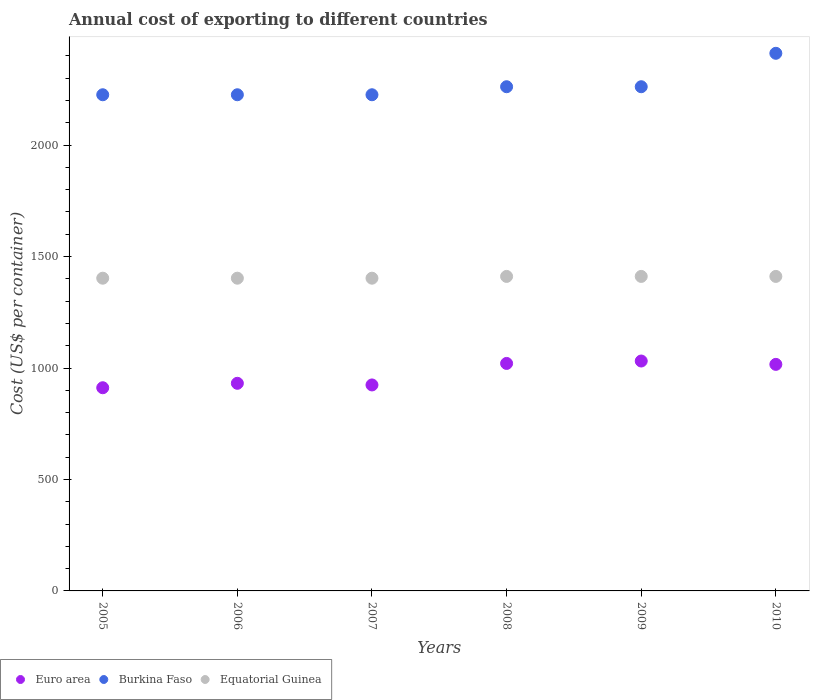Is the number of dotlines equal to the number of legend labels?
Keep it short and to the point. Yes. What is the total annual cost of exporting in Burkina Faso in 2009?
Your answer should be very brief. 2262. Across all years, what is the maximum total annual cost of exporting in Equatorial Guinea?
Offer a very short reply. 1411. Across all years, what is the minimum total annual cost of exporting in Equatorial Guinea?
Your answer should be compact. 1403. What is the total total annual cost of exporting in Burkina Faso in the graph?
Offer a very short reply. 1.36e+04. What is the difference between the total annual cost of exporting in Euro area in 2007 and that in 2009?
Your response must be concise. -107.33. What is the difference between the total annual cost of exporting in Euro area in 2006 and the total annual cost of exporting in Equatorial Guinea in 2005?
Offer a very short reply. -471.53. What is the average total annual cost of exporting in Equatorial Guinea per year?
Your response must be concise. 1407. In the year 2008, what is the difference between the total annual cost of exporting in Equatorial Guinea and total annual cost of exporting in Euro area?
Your answer should be very brief. 390.39. In how many years, is the total annual cost of exporting in Equatorial Guinea greater than 100 US$?
Provide a short and direct response. 6. What is the ratio of the total annual cost of exporting in Burkina Faso in 2005 to that in 2008?
Keep it short and to the point. 0.98. What is the difference between the highest and the second highest total annual cost of exporting in Burkina Faso?
Provide a succinct answer. 150. What is the difference between the highest and the lowest total annual cost of exporting in Euro area?
Your response must be concise. 119.88. In how many years, is the total annual cost of exporting in Burkina Faso greater than the average total annual cost of exporting in Burkina Faso taken over all years?
Ensure brevity in your answer.  1. How are the legend labels stacked?
Offer a very short reply. Horizontal. What is the title of the graph?
Make the answer very short. Annual cost of exporting to different countries. Does "Belarus" appear as one of the legend labels in the graph?
Your answer should be compact. No. What is the label or title of the X-axis?
Make the answer very short. Years. What is the label or title of the Y-axis?
Provide a short and direct response. Cost (US$ per container). What is the Cost (US$ per container) of Euro area in 2005?
Your answer should be very brief. 911.56. What is the Cost (US$ per container) in Burkina Faso in 2005?
Ensure brevity in your answer.  2226. What is the Cost (US$ per container) of Equatorial Guinea in 2005?
Provide a short and direct response. 1403. What is the Cost (US$ per container) in Euro area in 2006?
Make the answer very short. 931.47. What is the Cost (US$ per container) in Burkina Faso in 2006?
Provide a short and direct response. 2226. What is the Cost (US$ per container) in Equatorial Guinea in 2006?
Provide a succinct answer. 1403. What is the Cost (US$ per container) in Euro area in 2007?
Offer a terse response. 924.12. What is the Cost (US$ per container) of Burkina Faso in 2007?
Give a very brief answer. 2226. What is the Cost (US$ per container) of Equatorial Guinea in 2007?
Keep it short and to the point. 1403. What is the Cost (US$ per container) in Euro area in 2008?
Provide a succinct answer. 1020.61. What is the Cost (US$ per container) in Burkina Faso in 2008?
Offer a terse response. 2262. What is the Cost (US$ per container) of Equatorial Guinea in 2008?
Provide a short and direct response. 1411. What is the Cost (US$ per container) of Euro area in 2009?
Ensure brevity in your answer.  1031.44. What is the Cost (US$ per container) in Burkina Faso in 2009?
Make the answer very short. 2262. What is the Cost (US$ per container) in Equatorial Guinea in 2009?
Make the answer very short. 1411. What is the Cost (US$ per container) of Euro area in 2010?
Keep it short and to the point. 1016.39. What is the Cost (US$ per container) of Burkina Faso in 2010?
Your answer should be very brief. 2412. What is the Cost (US$ per container) in Equatorial Guinea in 2010?
Provide a succinct answer. 1411. Across all years, what is the maximum Cost (US$ per container) of Euro area?
Provide a succinct answer. 1031.44. Across all years, what is the maximum Cost (US$ per container) of Burkina Faso?
Provide a short and direct response. 2412. Across all years, what is the maximum Cost (US$ per container) of Equatorial Guinea?
Your response must be concise. 1411. Across all years, what is the minimum Cost (US$ per container) in Euro area?
Give a very brief answer. 911.56. Across all years, what is the minimum Cost (US$ per container) in Burkina Faso?
Your answer should be compact. 2226. Across all years, what is the minimum Cost (US$ per container) in Equatorial Guinea?
Ensure brevity in your answer.  1403. What is the total Cost (US$ per container) in Euro area in the graph?
Offer a very short reply. 5835.6. What is the total Cost (US$ per container) of Burkina Faso in the graph?
Give a very brief answer. 1.36e+04. What is the total Cost (US$ per container) of Equatorial Guinea in the graph?
Offer a very short reply. 8442. What is the difference between the Cost (US$ per container) of Euro area in 2005 and that in 2006?
Provide a succinct answer. -19.91. What is the difference between the Cost (US$ per container) in Euro area in 2005 and that in 2007?
Offer a terse response. -12.56. What is the difference between the Cost (US$ per container) in Equatorial Guinea in 2005 and that in 2007?
Your response must be concise. 0. What is the difference between the Cost (US$ per container) of Euro area in 2005 and that in 2008?
Make the answer very short. -109.05. What is the difference between the Cost (US$ per container) of Burkina Faso in 2005 and that in 2008?
Offer a terse response. -36. What is the difference between the Cost (US$ per container) in Euro area in 2005 and that in 2009?
Give a very brief answer. -119.88. What is the difference between the Cost (US$ per container) of Burkina Faso in 2005 and that in 2009?
Your answer should be very brief. -36. What is the difference between the Cost (US$ per container) of Equatorial Guinea in 2005 and that in 2009?
Offer a terse response. -8. What is the difference between the Cost (US$ per container) of Euro area in 2005 and that in 2010?
Keep it short and to the point. -104.83. What is the difference between the Cost (US$ per container) of Burkina Faso in 2005 and that in 2010?
Keep it short and to the point. -186. What is the difference between the Cost (US$ per container) of Euro area in 2006 and that in 2007?
Keep it short and to the point. 7.35. What is the difference between the Cost (US$ per container) of Burkina Faso in 2006 and that in 2007?
Give a very brief answer. 0. What is the difference between the Cost (US$ per container) of Equatorial Guinea in 2006 and that in 2007?
Ensure brevity in your answer.  0. What is the difference between the Cost (US$ per container) in Euro area in 2006 and that in 2008?
Ensure brevity in your answer.  -89.14. What is the difference between the Cost (US$ per container) in Burkina Faso in 2006 and that in 2008?
Make the answer very short. -36. What is the difference between the Cost (US$ per container) of Euro area in 2006 and that in 2009?
Your answer should be compact. -99.97. What is the difference between the Cost (US$ per container) in Burkina Faso in 2006 and that in 2009?
Give a very brief answer. -36. What is the difference between the Cost (US$ per container) in Euro area in 2006 and that in 2010?
Make the answer very short. -84.92. What is the difference between the Cost (US$ per container) in Burkina Faso in 2006 and that in 2010?
Offer a very short reply. -186. What is the difference between the Cost (US$ per container) of Equatorial Guinea in 2006 and that in 2010?
Your answer should be very brief. -8. What is the difference between the Cost (US$ per container) of Euro area in 2007 and that in 2008?
Your answer should be compact. -96.49. What is the difference between the Cost (US$ per container) of Burkina Faso in 2007 and that in 2008?
Your response must be concise. -36. What is the difference between the Cost (US$ per container) of Equatorial Guinea in 2007 and that in 2008?
Your answer should be compact. -8. What is the difference between the Cost (US$ per container) in Euro area in 2007 and that in 2009?
Your answer should be very brief. -107.33. What is the difference between the Cost (US$ per container) in Burkina Faso in 2007 and that in 2009?
Make the answer very short. -36. What is the difference between the Cost (US$ per container) in Euro area in 2007 and that in 2010?
Provide a short and direct response. -92.27. What is the difference between the Cost (US$ per container) of Burkina Faso in 2007 and that in 2010?
Offer a terse response. -186. What is the difference between the Cost (US$ per container) of Equatorial Guinea in 2007 and that in 2010?
Offer a very short reply. -8. What is the difference between the Cost (US$ per container) in Euro area in 2008 and that in 2009?
Offer a terse response. -10.83. What is the difference between the Cost (US$ per container) of Euro area in 2008 and that in 2010?
Your response must be concise. 4.22. What is the difference between the Cost (US$ per container) in Burkina Faso in 2008 and that in 2010?
Ensure brevity in your answer.  -150. What is the difference between the Cost (US$ per container) of Equatorial Guinea in 2008 and that in 2010?
Provide a short and direct response. 0. What is the difference between the Cost (US$ per container) in Euro area in 2009 and that in 2010?
Ensure brevity in your answer.  15.06. What is the difference between the Cost (US$ per container) in Burkina Faso in 2009 and that in 2010?
Offer a very short reply. -150. What is the difference between the Cost (US$ per container) in Euro area in 2005 and the Cost (US$ per container) in Burkina Faso in 2006?
Your answer should be very brief. -1314.44. What is the difference between the Cost (US$ per container) in Euro area in 2005 and the Cost (US$ per container) in Equatorial Guinea in 2006?
Offer a very short reply. -491.44. What is the difference between the Cost (US$ per container) in Burkina Faso in 2005 and the Cost (US$ per container) in Equatorial Guinea in 2006?
Your answer should be compact. 823. What is the difference between the Cost (US$ per container) in Euro area in 2005 and the Cost (US$ per container) in Burkina Faso in 2007?
Offer a terse response. -1314.44. What is the difference between the Cost (US$ per container) of Euro area in 2005 and the Cost (US$ per container) of Equatorial Guinea in 2007?
Your answer should be compact. -491.44. What is the difference between the Cost (US$ per container) of Burkina Faso in 2005 and the Cost (US$ per container) of Equatorial Guinea in 2007?
Make the answer very short. 823. What is the difference between the Cost (US$ per container) of Euro area in 2005 and the Cost (US$ per container) of Burkina Faso in 2008?
Your answer should be compact. -1350.44. What is the difference between the Cost (US$ per container) in Euro area in 2005 and the Cost (US$ per container) in Equatorial Guinea in 2008?
Your answer should be very brief. -499.44. What is the difference between the Cost (US$ per container) of Burkina Faso in 2005 and the Cost (US$ per container) of Equatorial Guinea in 2008?
Give a very brief answer. 815. What is the difference between the Cost (US$ per container) of Euro area in 2005 and the Cost (US$ per container) of Burkina Faso in 2009?
Offer a very short reply. -1350.44. What is the difference between the Cost (US$ per container) of Euro area in 2005 and the Cost (US$ per container) of Equatorial Guinea in 2009?
Offer a terse response. -499.44. What is the difference between the Cost (US$ per container) in Burkina Faso in 2005 and the Cost (US$ per container) in Equatorial Guinea in 2009?
Keep it short and to the point. 815. What is the difference between the Cost (US$ per container) of Euro area in 2005 and the Cost (US$ per container) of Burkina Faso in 2010?
Your response must be concise. -1500.44. What is the difference between the Cost (US$ per container) of Euro area in 2005 and the Cost (US$ per container) of Equatorial Guinea in 2010?
Your answer should be very brief. -499.44. What is the difference between the Cost (US$ per container) in Burkina Faso in 2005 and the Cost (US$ per container) in Equatorial Guinea in 2010?
Provide a succinct answer. 815. What is the difference between the Cost (US$ per container) of Euro area in 2006 and the Cost (US$ per container) of Burkina Faso in 2007?
Offer a terse response. -1294.53. What is the difference between the Cost (US$ per container) in Euro area in 2006 and the Cost (US$ per container) in Equatorial Guinea in 2007?
Give a very brief answer. -471.53. What is the difference between the Cost (US$ per container) in Burkina Faso in 2006 and the Cost (US$ per container) in Equatorial Guinea in 2007?
Your answer should be very brief. 823. What is the difference between the Cost (US$ per container) in Euro area in 2006 and the Cost (US$ per container) in Burkina Faso in 2008?
Keep it short and to the point. -1330.53. What is the difference between the Cost (US$ per container) in Euro area in 2006 and the Cost (US$ per container) in Equatorial Guinea in 2008?
Your response must be concise. -479.53. What is the difference between the Cost (US$ per container) in Burkina Faso in 2006 and the Cost (US$ per container) in Equatorial Guinea in 2008?
Offer a very short reply. 815. What is the difference between the Cost (US$ per container) of Euro area in 2006 and the Cost (US$ per container) of Burkina Faso in 2009?
Provide a succinct answer. -1330.53. What is the difference between the Cost (US$ per container) of Euro area in 2006 and the Cost (US$ per container) of Equatorial Guinea in 2009?
Offer a very short reply. -479.53. What is the difference between the Cost (US$ per container) of Burkina Faso in 2006 and the Cost (US$ per container) of Equatorial Guinea in 2009?
Your answer should be compact. 815. What is the difference between the Cost (US$ per container) in Euro area in 2006 and the Cost (US$ per container) in Burkina Faso in 2010?
Your answer should be compact. -1480.53. What is the difference between the Cost (US$ per container) of Euro area in 2006 and the Cost (US$ per container) of Equatorial Guinea in 2010?
Your response must be concise. -479.53. What is the difference between the Cost (US$ per container) in Burkina Faso in 2006 and the Cost (US$ per container) in Equatorial Guinea in 2010?
Provide a succinct answer. 815. What is the difference between the Cost (US$ per container) in Euro area in 2007 and the Cost (US$ per container) in Burkina Faso in 2008?
Ensure brevity in your answer.  -1337.88. What is the difference between the Cost (US$ per container) in Euro area in 2007 and the Cost (US$ per container) in Equatorial Guinea in 2008?
Your response must be concise. -486.88. What is the difference between the Cost (US$ per container) of Burkina Faso in 2007 and the Cost (US$ per container) of Equatorial Guinea in 2008?
Your response must be concise. 815. What is the difference between the Cost (US$ per container) of Euro area in 2007 and the Cost (US$ per container) of Burkina Faso in 2009?
Make the answer very short. -1337.88. What is the difference between the Cost (US$ per container) of Euro area in 2007 and the Cost (US$ per container) of Equatorial Guinea in 2009?
Offer a terse response. -486.88. What is the difference between the Cost (US$ per container) of Burkina Faso in 2007 and the Cost (US$ per container) of Equatorial Guinea in 2009?
Make the answer very short. 815. What is the difference between the Cost (US$ per container) of Euro area in 2007 and the Cost (US$ per container) of Burkina Faso in 2010?
Provide a succinct answer. -1487.88. What is the difference between the Cost (US$ per container) of Euro area in 2007 and the Cost (US$ per container) of Equatorial Guinea in 2010?
Give a very brief answer. -486.88. What is the difference between the Cost (US$ per container) in Burkina Faso in 2007 and the Cost (US$ per container) in Equatorial Guinea in 2010?
Give a very brief answer. 815. What is the difference between the Cost (US$ per container) in Euro area in 2008 and the Cost (US$ per container) in Burkina Faso in 2009?
Your answer should be very brief. -1241.39. What is the difference between the Cost (US$ per container) of Euro area in 2008 and the Cost (US$ per container) of Equatorial Guinea in 2009?
Offer a terse response. -390.39. What is the difference between the Cost (US$ per container) in Burkina Faso in 2008 and the Cost (US$ per container) in Equatorial Guinea in 2009?
Give a very brief answer. 851. What is the difference between the Cost (US$ per container) of Euro area in 2008 and the Cost (US$ per container) of Burkina Faso in 2010?
Offer a very short reply. -1391.39. What is the difference between the Cost (US$ per container) of Euro area in 2008 and the Cost (US$ per container) of Equatorial Guinea in 2010?
Your response must be concise. -390.39. What is the difference between the Cost (US$ per container) of Burkina Faso in 2008 and the Cost (US$ per container) of Equatorial Guinea in 2010?
Keep it short and to the point. 851. What is the difference between the Cost (US$ per container) of Euro area in 2009 and the Cost (US$ per container) of Burkina Faso in 2010?
Give a very brief answer. -1380.56. What is the difference between the Cost (US$ per container) of Euro area in 2009 and the Cost (US$ per container) of Equatorial Guinea in 2010?
Provide a succinct answer. -379.56. What is the difference between the Cost (US$ per container) of Burkina Faso in 2009 and the Cost (US$ per container) of Equatorial Guinea in 2010?
Your response must be concise. 851. What is the average Cost (US$ per container) in Euro area per year?
Provide a succinct answer. 972.6. What is the average Cost (US$ per container) in Burkina Faso per year?
Your answer should be very brief. 2269. What is the average Cost (US$ per container) of Equatorial Guinea per year?
Keep it short and to the point. 1407. In the year 2005, what is the difference between the Cost (US$ per container) in Euro area and Cost (US$ per container) in Burkina Faso?
Your response must be concise. -1314.44. In the year 2005, what is the difference between the Cost (US$ per container) of Euro area and Cost (US$ per container) of Equatorial Guinea?
Keep it short and to the point. -491.44. In the year 2005, what is the difference between the Cost (US$ per container) in Burkina Faso and Cost (US$ per container) in Equatorial Guinea?
Your answer should be very brief. 823. In the year 2006, what is the difference between the Cost (US$ per container) of Euro area and Cost (US$ per container) of Burkina Faso?
Provide a succinct answer. -1294.53. In the year 2006, what is the difference between the Cost (US$ per container) of Euro area and Cost (US$ per container) of Equatorial Guinea?
Your response must be concise. -471.53. In the year 2006, what is the difference between the Cost (US$ per container) in Burkina Faso and Cost (US$ per container) in Equatorial Guinea?
Offer a terse response. 823. In the year 2007, what is the difference between the Cost (US$ per container) of Euro area and Cost (US$ per container) of Burkina Faso?
Your answer should be compact. -1301.88. In the year 2007, what is the difference between the Cost (US$ per container) in Euro area and Cost (US$ per container) in Equatorial Guinea?
Ensure brevity in your answer.  -478.88. In the year 2007, what is the difference between the Cost (US$ per container) in Burkina Faso and Cost (US$ per container) in Equatorial Guinea?
Offer a very short reply. 823. In the year 2008, what is the difference between the Cost (US$ per container) of Euro area and Cost (US$ per container) of Burkina Faso?
Make the answer very short. -1241.39. In the year 2008, what is the difference between the Cost (US$ per container) in Euro area and Cost (US$ per container) in Equatorial Guinea?
Offer a very short reply. -390.39. In the year 2008, what is the difference between the Cost (US$ per container) of Burkina Faso and Cost (US$ per container) of Equatorial Guinea?
Your answer should be very brief. 851. In the year 2009, what is the difference between the Cost (US$ per container) in Euro area and Cost (US$ per container) in Burkina Faso?
Offer a very short reply. -1230.56. In the year 2009, what is the difference between the Cost (US$ per container) of Euro area and Cost (US$ per container) of Equatorial Guinea?
Give a very brief answer. -379.56. In the year 2009, what is the difference between the Cost (US$ per container) of Burkina Faso and Cost (US$ per container) of Equatorial Guinea?
Your answer should be compact. 851. In the year 2010, what is the difference between the Cost (US$ per container) of Euro area and Cost (US$ per container) of Burkina Faso?
Provide a succinct answer. -1395.61. In the year 2010, what is the difference between the Cost (US$ per container) of Euro area and Cost (US$ per container) of Equatorial Guinea?
Provide a short and direct response. -394.61. In the year 2010, what is the difference between the Cost (US$ per container) in Burkina Faso and Cost (US$ per container) in Equatorial Guinea?
Your answer should be compact. 1001. What is the ratio of the Cost (US$ per container) of Euro area in 2005 to that in 2006?
Ensure brevity in your answer.  0.98. What is the ratio of the Cost (US$ per container) in Equatorial Guinea in 2005 to that in 2006?
Your answer should be compact. 1. What is the ratio of the Cost (US$ per container) of Euro area in 2005 to that in 2007?
Keep it short and to the point. 0.99. What is the ratio of the Cost (US$ per container) in Euro area in 2005 to that in 2008?
Provide a short and direct response. 0.89. What is the ratio of the Cost (US$ per container) in Burkina Faso in 2005 to that in 2008?
Your response must be concise. 0.98. What is the ratio of the Cost (US$ per container) in Equatorial Guinea in 2005 to that in 2008?
Make the answer very short. 0.99. What is the ratio of the Cost (US$ per container) of Euro area in 2005 to that in 2009?
Your answer should be very brief. 0.88. What is the ratio of the Cost (US$ per container) in Burkina Faso in 2005 to that in 2009?
Offer a very short reply. 0.98. What is the ratio of the Cost (US$ per container) of Equatorial Guinea in 2005 to that in 2009?
Your answer should be compact. 0.99. What is the ratio of the Cost (US$ per container) in Euro area in 2005 to that in 2010?
Ensure brevity in your answer.  0.9. What is the ratio of the Cost (US$ per container) in Burkina Faso in 2005 to that in 2010?
Provide a short and direct response. 0.92. What is the ratio of the Cost (US$ per container) of Burkina Faso in 2006 to that in 2007?
Your answer should be compact. 1. What is the ratio of the Cost (US$ per container) in Euro area in 2006 to that in 2008?
Provide a short and direct response. 0.91. What is the ratio of the Cost (US$ per container) of Burkina Faso in 2006 to that in 2008?
Your response must be concise. 0.98. What is the ratio of the Cost (US$ per container) in Equatorial Guinea in 2006 to that in 2008?
Keep it short and to the point. 0.99. What is the ratio of the Cost (US$ per container) of Euro area in 2006 to that in 2009?
Your response must be concise. 0.9. What is the ratio of the Cost (US$ per container) in Burkina Faso in 2006 to that in 2009?
Offer a terse response. 0.98. What is the ratio of the Cost (US$ per container) in Euro area in 2006 to that in 2010?
Ensure brevity in your answer.  0.92. What is the ratio of the Cost (US$ per container) of Burkina Faso in 2006 to that in 2010?
Your response must be concise. 0.92. What is the ratio of the Cost (US$ per container) of Equatorial Guinea in 2006 to that in 2010?
Keep it short and to the point. 0.99. What is the ratio of the Cost (US$ per container) of Euro area in 2007 to that in 2008?
Offer a terse response. 0.91. What is the ratio of the Cost (US$ per container) of Burkina Faso in 2007 to that in 2008?
Your answer should be very brief. 0.98. What is the ratio of the Cost (US$ per container) in Euro area in 2007 to that in 2009?
Give a very brief answer. 0.9. What is the ratio of the Cost (US$ per container) in Burkina Faso in 2007 to that in 2009?
Your response must be concise. 0.98. What is the ratio of the Cost (US$ per container) in Equatorial Guinea in 2007 to that in 2009?
Keep it short and to the point. 0.99. What is the ratio of the Cost (US$ per container) in Euro area in 2007 to that in 2010?
Give a very brief answer. 0.91. What is the ratio of the Cost (US$ per container) in Burkina Faso in 2007 to that in 2010?
Keep it short and to the point. 0.92. What is the ratio of the Cost (US$ per container) of Equatorial Guinea in 2007 to that in 2010?
Ensure brevity in your answer.  0.99. What is the ratio of the Cost (US$ per container) in Burkina Faso in 2008 to that in 2009?
Make the answer very short. 1. What is the ratio of the Cost (US$ per container) of Equatorial Guinea in 2008 to that in 2009?
Give a very brief answer. 1. What is the ratio of the Cost (US$ per container) of Burkina Faso in 2008 to that in 2010?
Your answer should be compact. 0.94. What is the ratio of the Cost (US$ per container) in Equatorial Guinea in 2008 to that in 2010?
Offer a terse response. 1. What is the ratio of the Cost (US$ per container) in Euro area in 2009 to that in 2010?
Offer a very short reply. 1.01. What is the ratio of the Cost (US$ per container) of Burkina Faso in 2009 to that in 2010?
Keep it short and to the point. 0.94. What is the ratio of the Cost (US$ per container) in Equatorial Guinea in 2009 to that in 2010?
Your response must be concise. 1. What is the difference between the highest and the second highest Cost (US$ per container) in Euro area?
Offer a very short reply. 10.83. What is the difference between the highest and the second highest Cost (US$ per container) in Burkina Faso?
Provide a succinct answer. 150. What is the difference between the highest and the second highest Cost (US$ per container) of Equatorial Guinea?
Make the answer very short. 0. What is the difference between the highest and the lowest Cost (US$ per container) of Euro area?
Your answer should be compact. 119.88. What is the difference between the highest and the lowest Cost (US$ per container) in Burkina Faso?
Give a very brief answer. 186. 